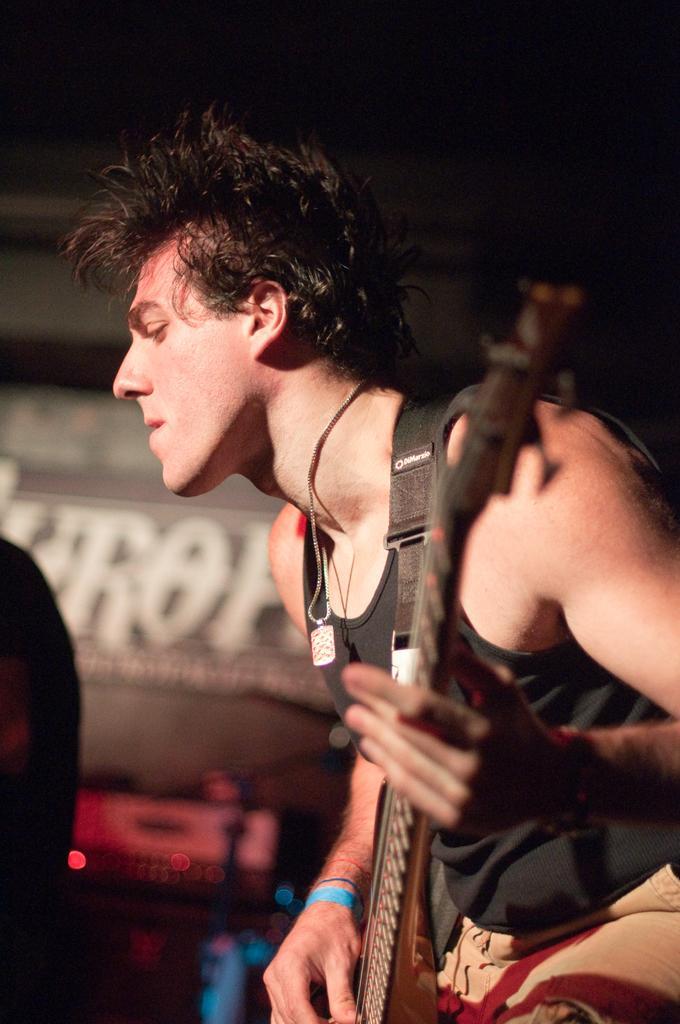Please provide a concise description of this image. In this image I can see a person holding the guitar. 